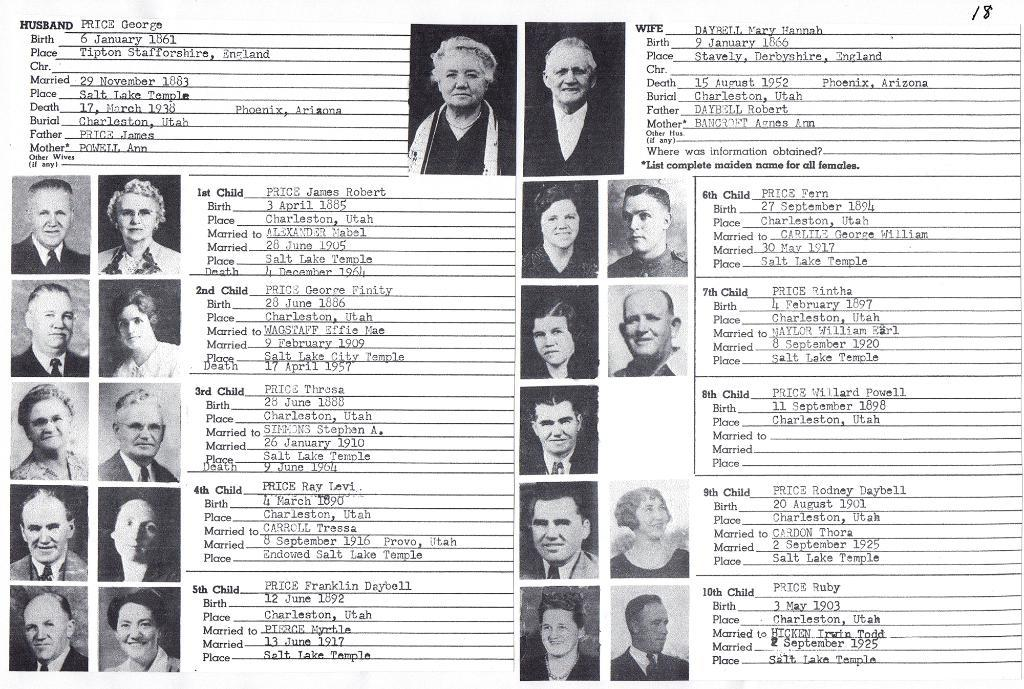What can be seen in the image? There are photos and text in the image. What is the color of the background in the image? The background of the image is white. Can you tell me how many trains are depicted in the image? There are no trains present in the image; it features photos and text. What type of competition is shown in the image? There is no competition depicted in the image; it only contains photos and text. 